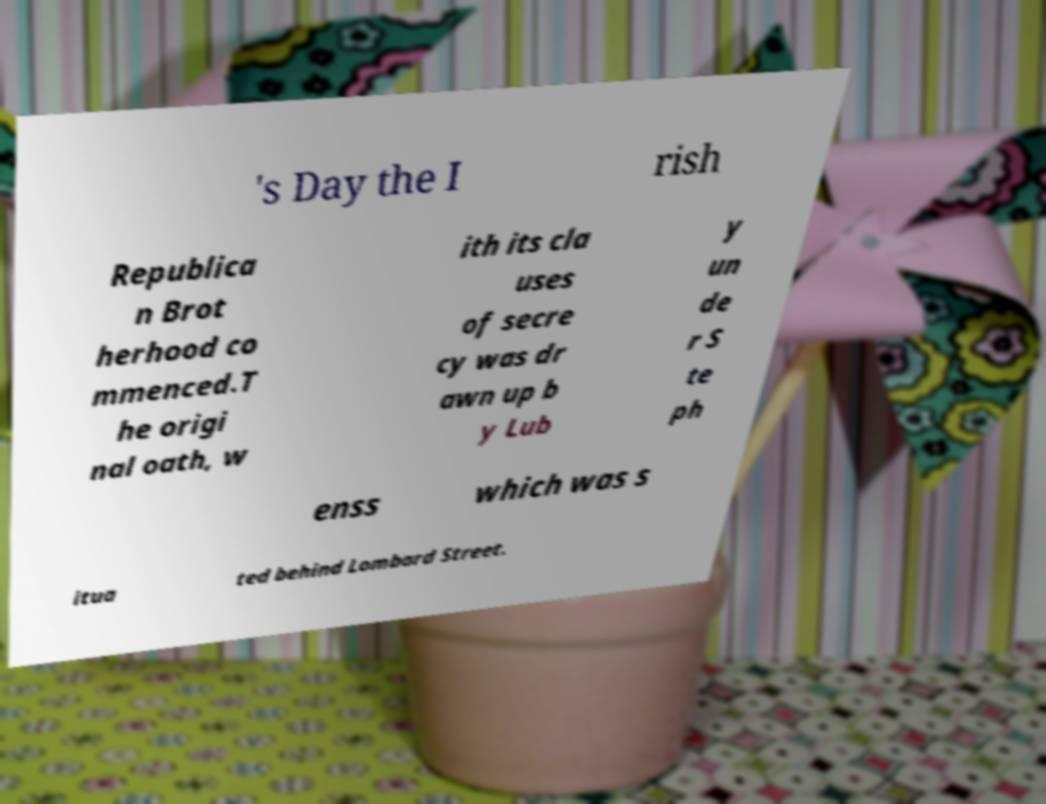Could you extract and type out the text from this image? 's Day the I rish Republica n Brot herhood co mmenced.T he origi nal oath, w ith its cla uses of secre cy was dr awn up b y Lub y un de r S te ph enss which was s itua ted behind Lombard Street. 